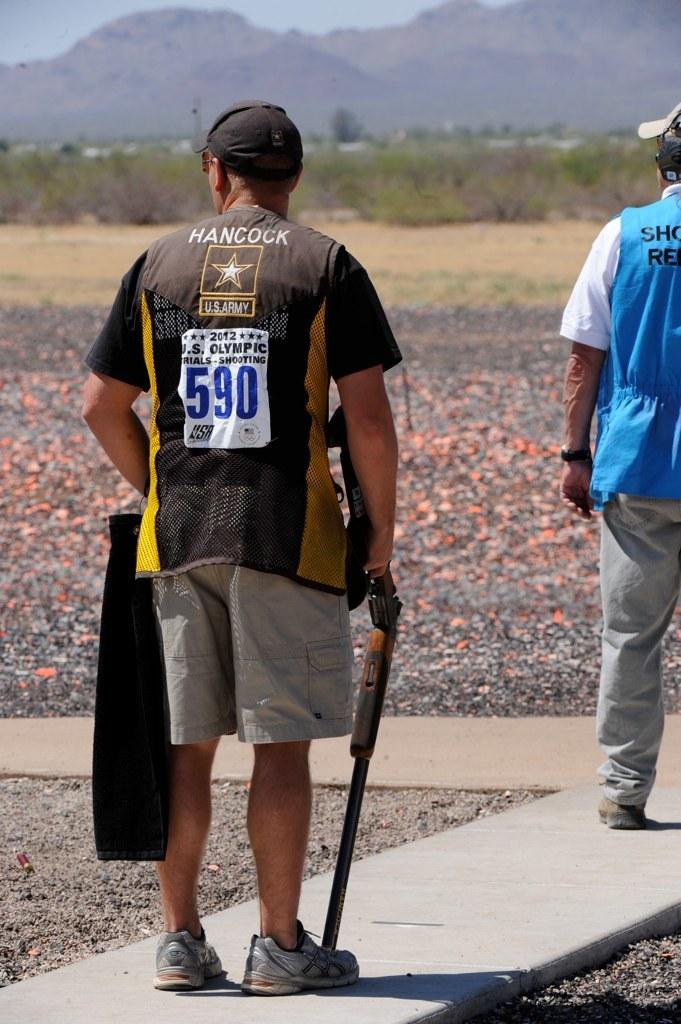<image>
Write a terse but informative summary of the picture. A man with the number 590 on his back is holding a shotgun. 